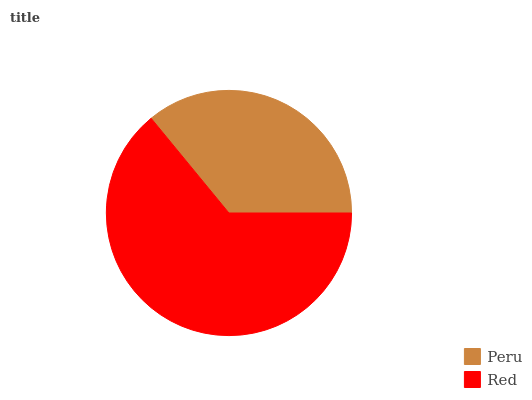Is Peru the minimum?
Answer yes or no. Yes. Is Red the maximum?
Answer yes or no. Yes. Is Red the minimum?
Answer yes or no. No. Is Red greater than Peru?
Answer yes or no. Yes. Is Peru less than Red?
Answer yes or no. Yes. Is Peru greater than Red?
Answer yes or no. No. Is Red less than Peru?
Answer yes or no. No. Is Red the high median?
Answer yes or no. Yes. Is Peru the low median?
Answer yes or no. Yes. Is Peru the high median?
Answer yes or no. No. Is Red the low median?
Answer yes or no. No. 